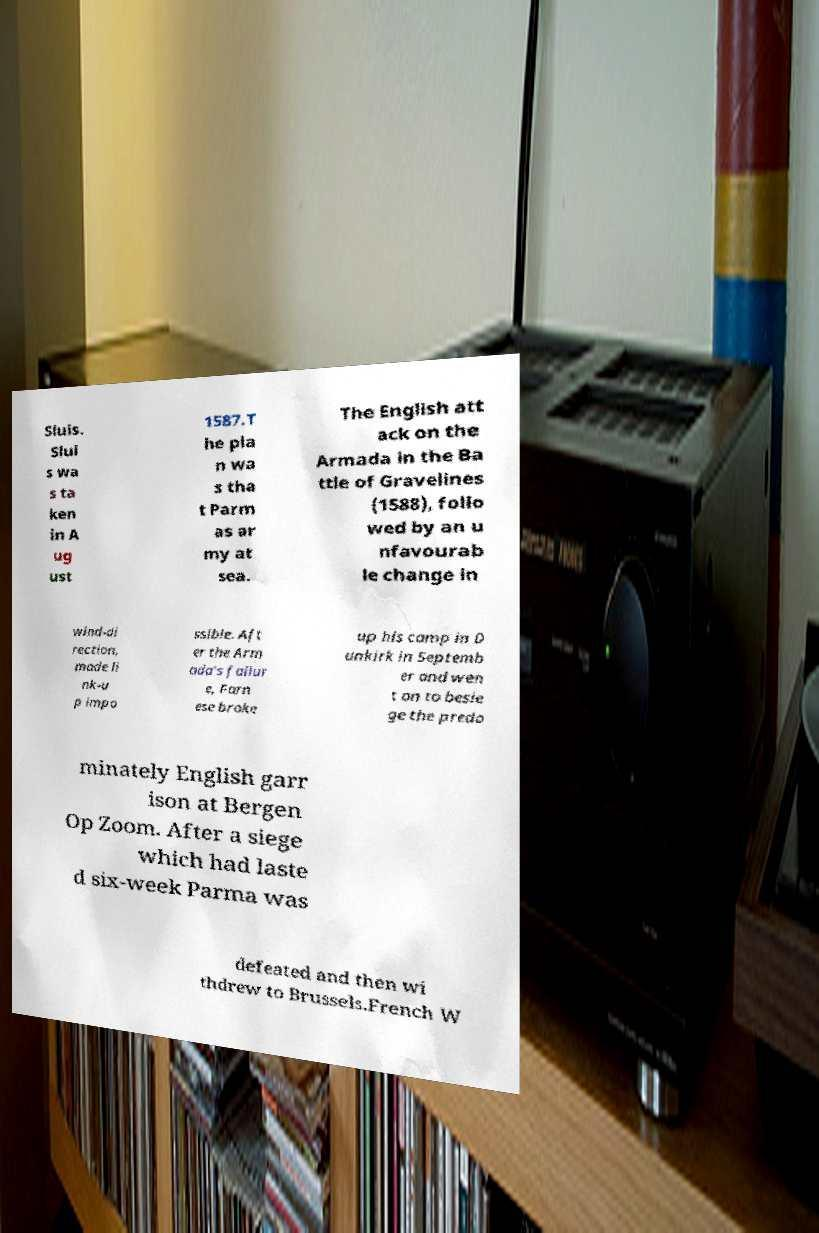I need the written content from this picture converted into text. Can you do that? Sluis. Slui s wa s ta ken in A ug ust 1587.T he pla n wa s tha t Parm as ar my at sea. The English att ack on the Armada in the Ba ttle of Gravelines (1588), follo wed by an u nfavourab le change in wind-di rection, made li nk-u p impo ssible. Aft er the Arm ada's failur e, Farn ese broke up his camp in D unkirk in Septemb er and wen t on to besie ge the predo minately English garr ison at Bergen Op Zoom. After a siege which had laste d six-week Parma was defeated and then wi thdrew to Brussels.French W 